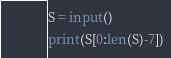Convert code to text. <code><loc_0><loc_0><loc_500><loc_500><_Python_>S = input()
print(S[0:len(S)-7])</code> 